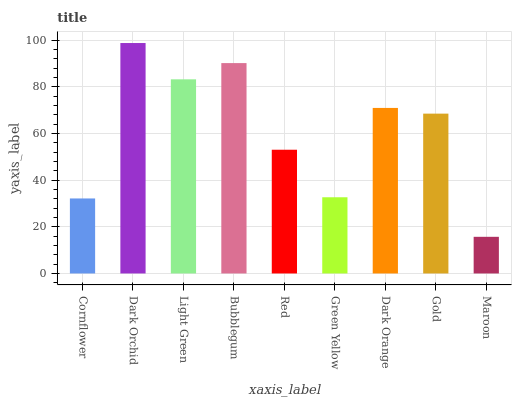Is Maroon the minimum?
Answer yes or no. Yes. Is Dark Orchid the maximum?
Answer yes or no. Yes. Is Light Green the minimum?
Answer yes or no. No. Is Light Green the maximum?
Answer yes or no. No. Is Dark Orchid greater than Light Green?
Answer yes or no. Yes. Is Light Green less than Dark Orchid?
Answer yes or no. Yes. Is Light Green greater than Dark Orchid?
Answer yes or no. No. Is Dark Orchid less than Light Green?
Answer yes or no. No. Is Gold the high median?
Answer yes or no. Yes. Is Gold the low median?
Answer yes or no. Yes. Is Green Yellow the high median?
Answer yes or no. No. Is Green Yellow the low median?
Answer yes or no. No. 